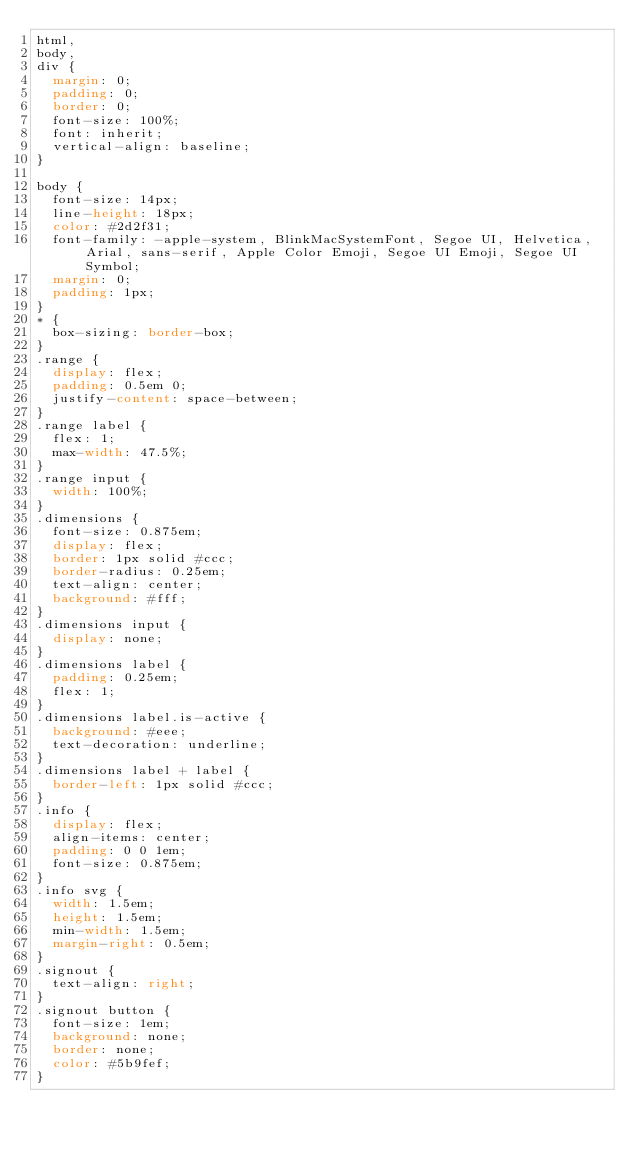<code> <loc_0><loc_0><loc_500><loc_500><_CSS_>html,
body,
div {
  margin: 0;
  padding: 0;
  border: 0;
  font-size: 100%;
  font: inherit;
  vertical-align: baseline;
}

body {
  font-size: 14px;
  line-height: 18px;
  color: #2d2f31;
  font-family: -apple-system, BlinkMacSystemFont, Segoe UI, Helvetica, Arial, sans-serif, Apple Color Emoji, Segoe UI Emoji, Segoe UI Symbol;
  margin: 0;
  padding: 1px;
}
* {
  box-sizing: border-box;
}
.range {
  display: flex;
  padding: 0.5em 0;
  justify-content: space-between;
}
.range label {
  flex: 1;
  max-width: 47.5%;
}
.range input {
  width: 100%;
}
.dimensions {
  font-size: 0.875em;
  display: flex;
  border: 1px solid #ccc;
  border-radius: 0.25em;
  text-align: center;
  background: #fff;
}
.dimensions input {
  display: none;
}
.dimensions label {
  padding: 0.25em;
  flex: 1;
}
.dimensions label.is-active {
  background: #eee;
  text-decoration: underline;
}
.dimensions label + label {
  border-left: 1px solid #ccc;
}
.info {
  display: flex;
  align-items: center;
  padding: 0 0 1em;
  font-size: 0.875em;
}
.info svg {
  width: 1.5em;
  height: 1.5em;
  min-width: 1.5em;
  margin-right: 0.5em;
}
.signout {
  text-align: right;
}
.signout button {
  font-size: 1em;
  background: none;
  border: none;
  color: #5b9fef;
}
</code> 